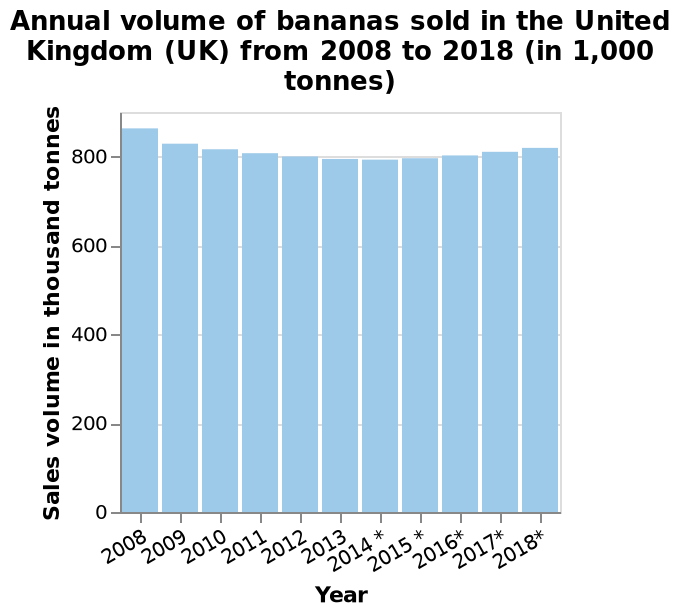<image>
What is the name of the chart?  The chart is named "Annual volume of bananas sold in the United Kingdom (UK) from 2008 to 2018 (in 1,000 tonnes)." What time period does the chart cover? The chart covers the years from 2008 to 2018. please enumerates aspects of the construction of the chart This is a bar chart named Annual volume of bananas sold in the United Kingdom (UK) from 2008 to 2018 (in 1,000 tonnes). A linear scale of range 0 to 800 can be found along the y-axis, marked Sales volume in thousand tonnes. A categorical scale starting with 2008 and ending with 2018* can be seen along the x-axis, marked Year. What is the scale on the x-axis?  The x-axis has a categorical scale starting with the year 2008 and ending with the year 2018. Has there been any change in the volume of bananas sold in the UK from 2024 to 2028?  Yes, there has been a slight increase in the volume of bananas sold in the UK from 2024. 